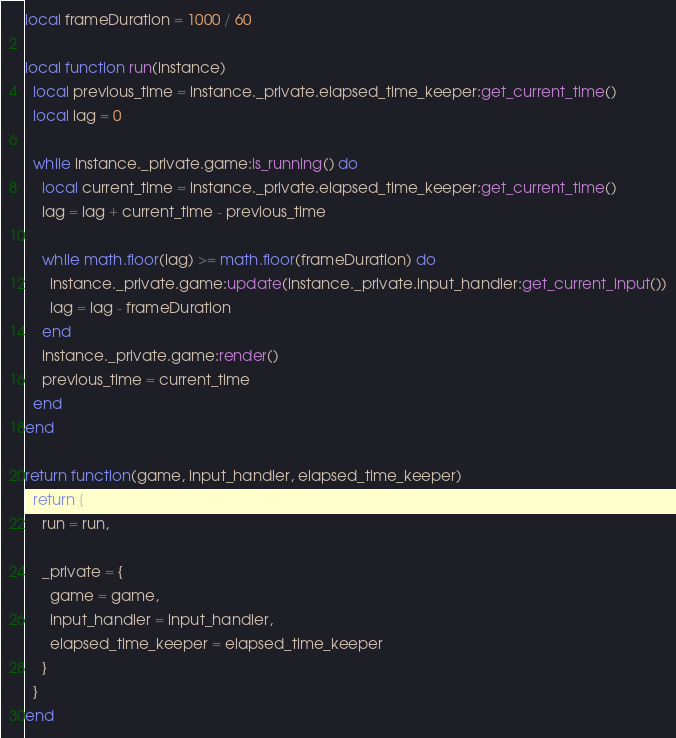<code> <loc_0><loc_0><loc_500><loc_500><_Lua_>local frameDuration = 1000 / 60

local function run(instance)
  local previous_time = instance._private.elapsed_time_keeper:get_current_time()
  local lag = 0

  while instance._private.game:is_running() do
    local current_time = instance._private.elapsed_time_keeper:get_current_time()
    lag = lag + current_time - previous_time

    while math.floor(lag) >= math.floor(frameDuration) do
      instance._private.game:update(instance._private.input_handler:get_current_input())
      lag = lag - frameDuration
    end
    instance._private.game:render()
    previous_time = current_time
  end
end

return function(game, input_handler, elapsed_time_keeper)
  return {
    run = run,

    _private = {
      game = game,
      input_handler = input_handler,
      elapsed_time_keeper = elapsed_time_keeper
    }
  }
end
</code> 